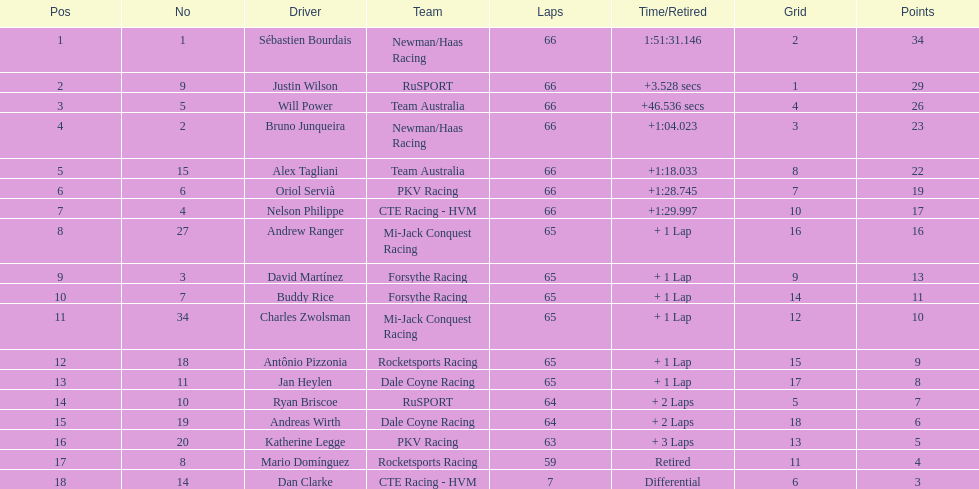Which country is represented by the most drivers? United Kingdom. 